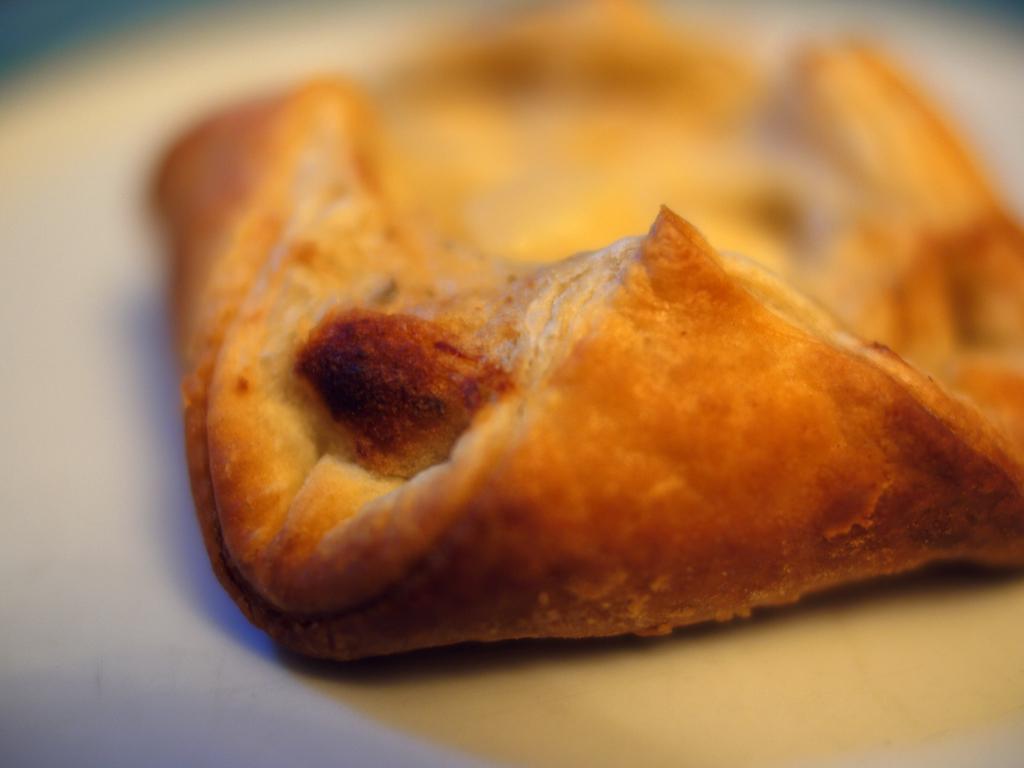Describe this image in one or two sentences. In this picture, we see a white plate containing a puff pastry. This picture is blurred in the background. 